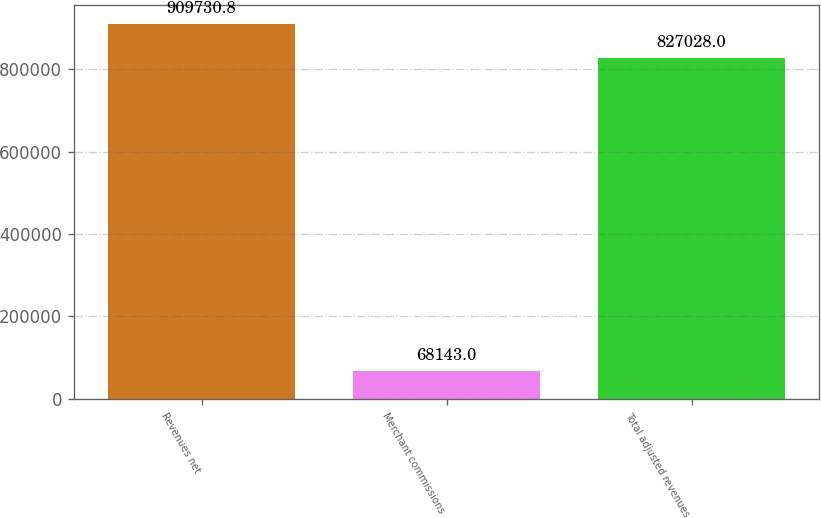Convert chart. <chart><loc_0><loc_0><loc_500><loc_500><bar_chart><fcel>Revenues net<fcel>Merchant commissions<fcel>Total adjusted revenues<nl><fcel>909731<fcel>68143<fcel>827028<nl></chart> 